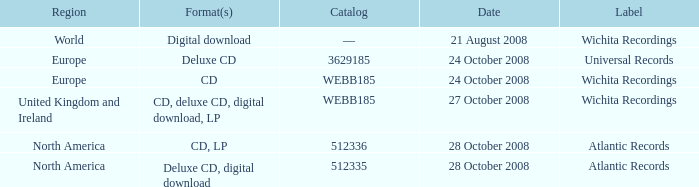Could you parse the entire table? {'header': ['Region', 'Format(s)', 'Catalog', 'Date', 'Label'], 'rows': [['World', 'Digital download', '—', '21 August 2008', 'Wichita Recordings'], ['Europe', 'Deluxe CD', '3629185', '24 October 2008', 'Universal Records'], ['Europe', 'CD', 'WEBB185', '24 October 2008', 'Wichita Recordings'], ['United Kingdom and Ireland', 'CD, deluxe CD, digital download, LP', 'WEBB185', '27 October 2008', 'Wichita Recordings'], ['North America', 'CD, LP', '512336', '28 October 2008', 'Atlantic Records'], ['North America', 'Deluxe CD, digital download', '512335', '28 October 2008', 'Atlantic Records']]} What are the formats associated with the Atlantic Records label, catalog number 512336? CD, LP. 